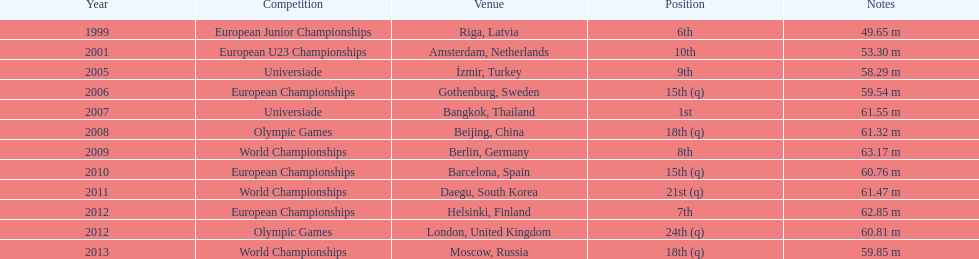Regarding mayer's best performance, how far was his longest throw? 63.17 m. 